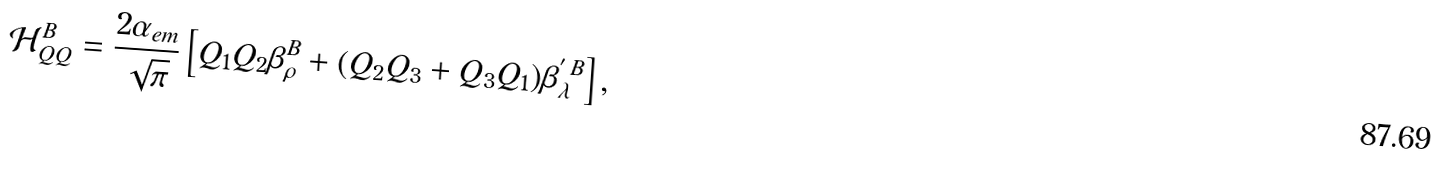Convert formula to latex. <formula><loc_0><loc_0><loc_500><loc_500>\mathcal { H } _ { Q Q } ^ { B } = \frac { 2 \alpha _ { e m } } { \sqrt { \pi } } \left [ Q _ { 1 } Q _ { 2 } \beta _ { \rho } ^ { B } + ( Q _ { 2 } Q _ { 3 } + Q _ { 3 } Q _ { 1 } ) \beta _ { \lambda } ^ { ^ { \prime } \, B } \right ] ,</formula> 